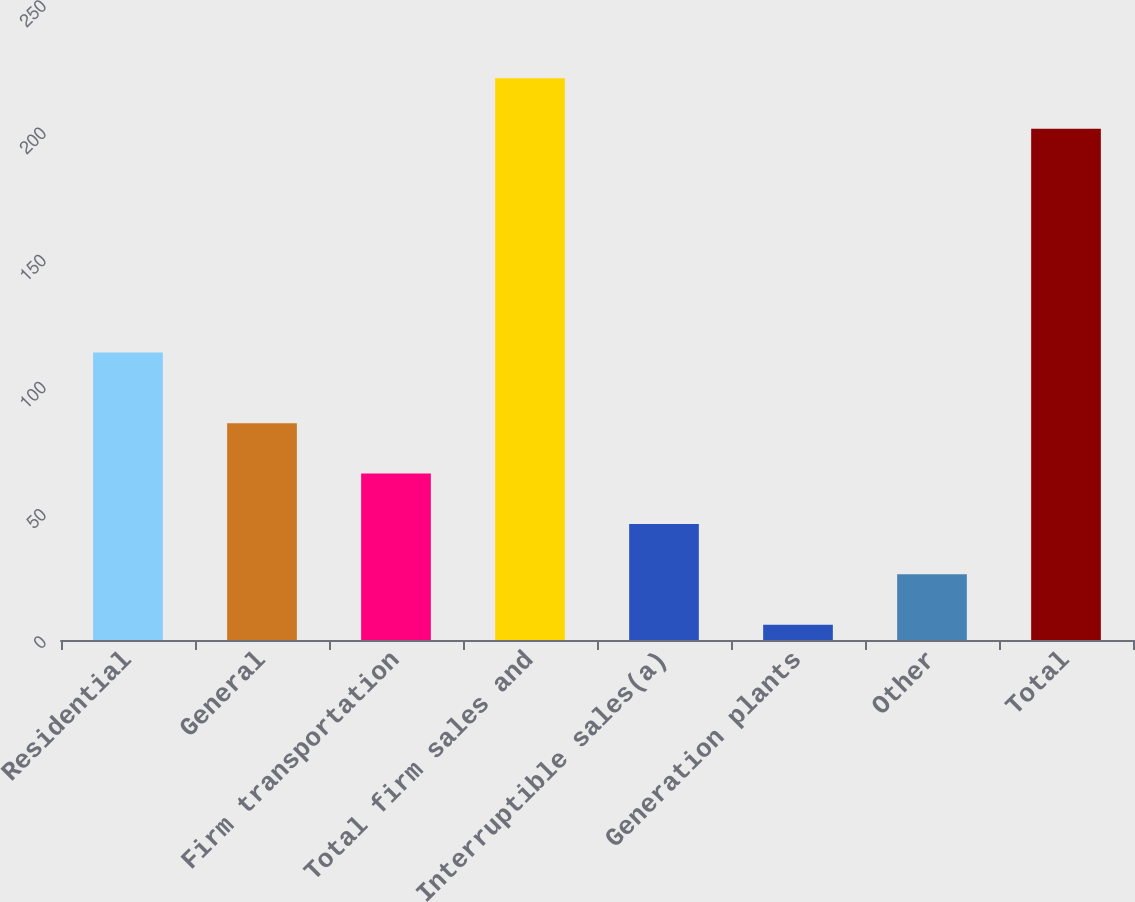<chart> <loc_0><loc_0><loc_500><loc_500><bar_chart><fcel>Residential<fcel>General<fcel>Firm transportation<fcel>Total firm sales and<fcel>Interruptible sales(a)<fcel>Generation plants<fcel>Other<fcel>Total<nl><fcel>113<fcel>85.2<fcel>65.4<fcel>220.8<fcel>45.6<fcel>6<fcel>25.8<fcel>201<nl></chart> 